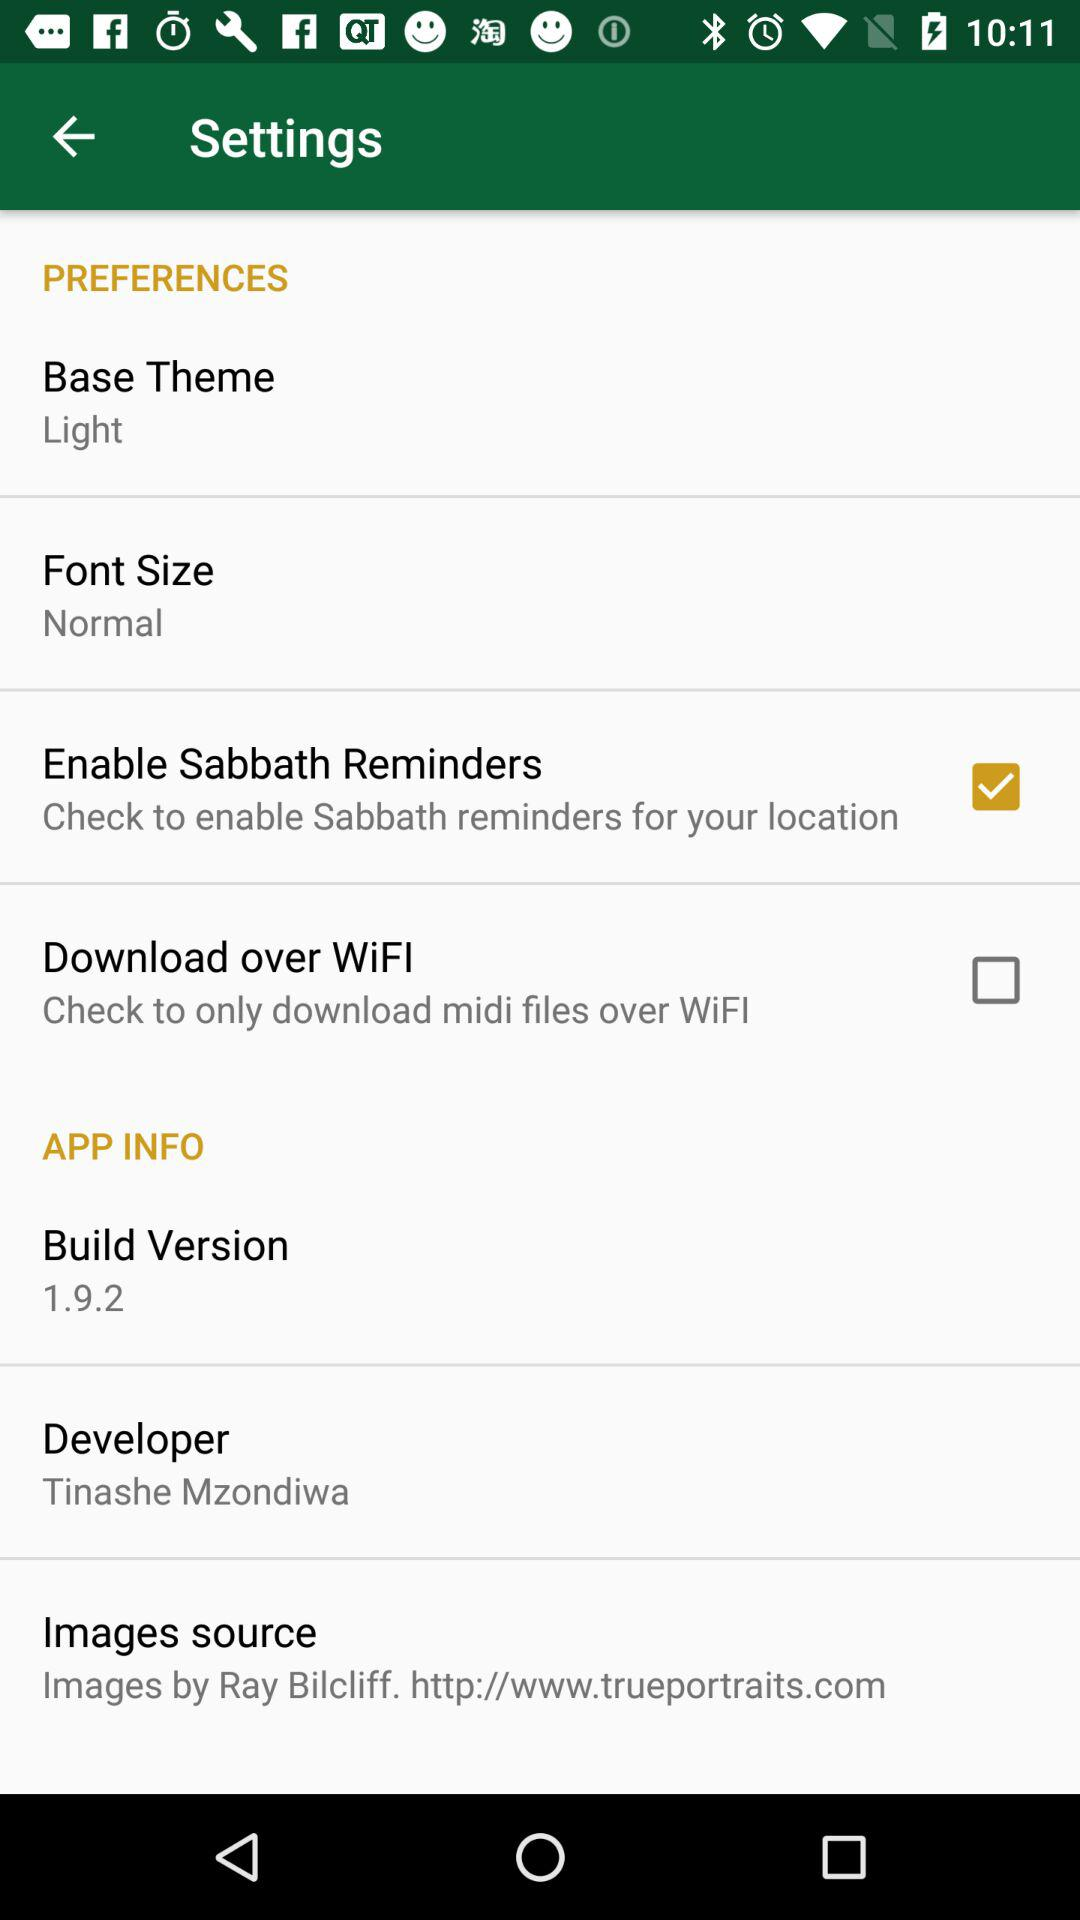What is the "Font Size"? The font size is "Normal". 